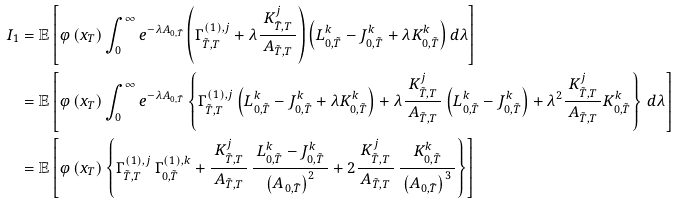<formula> <loc_0><loc_0><loc_500><loc_500>I _ { 1 } & = \mathbb { E } \left [ \varphi \left ( x _ { T } \right ) \int _ { 0 } ^ { \infty } e ^ { - \lambda A _ { 0 , \tilde { T } } } \left ( \Gamma _ { \tilde { T } , T } ^ { ( 1 ) , j } + \lambda \frac { K _ { \tilde { T } , T } ^ { j } } { \, A _ { \tilde { T } , T } \, } \right ) \left ( L _ { 0 , \tilde { T } } ^ { k } - J _ { 0 , \tilde { T } } ^ { k } + \lambda K _ { 0 , \tilde { T } } ^ { k } \right ) d \lambda \right ] \\ & = \mathbb { E } \left [ \varphi \left ( x _ { T } \right ) \int _ { 0 } ^ { \infty } e ^ { - \lambda A _ { 0 , \tilde { T } } } \left \{ \Gamma _ { \tilde { T } , T } ^ { ( 1 ) , j } \left ( L _ { 0 , \tilde { T } } ^ { k } - J _ { 0 , \tilde { T } } ^ { k } + \lambda K _ { 0 , \tilde { T } } ^ { k } \right ) + \lambda \frac { K _ { \tilde { T } , T } ^ { j } } { \, A _ { \tilde { T } , T } \, } \left ( L _ { 0 , \tilde { T } } ^ { k } - J _ { 0 , \tilde { T } } ^ { k } \right ) + \lambda ^ { 2 } \frac { K _ { \tilde { T } , T } ^ { j } } { \, A _ { \tilde { T } , T } \, } K _ { 0 , \tilde { T } } ^ { k } \right \} \, d \lambda \right ] \\ & = \mathbb { E } \left [ \varphi \left ( x _ { T } \right ) \left \{ \Gamma _ { \tilde { T } , T } ^ { ( 1 ) , j } \, \Gamma _ { 0 , \tilde { T } } ^ { ( 1 ) , k } + \frac { K _ { \tilde { T } , T } ^ { j } } { \, A _ { \tilde { T } , T } \, } \, \frac { \, L _ { 0 , \tilde { T } } ^ { k } - J _ { 0 , \tilde { T } } ^ { k } \, } { \left ( A _ { 0 , \tilde { T } } \right ) ^ { 2 } } + 2 \frac { K _ { \tilde { T } , T } ^ { j } } { \, A _ { \tilde { T } , T } \, } \, \frac { K _ { 0 , \tilde { T } } ^ { k } } { \, \left ( A _ { 0 , \tilde { T } } \right ) ^ { 3 } \, } \right \} \right ]</formula> 